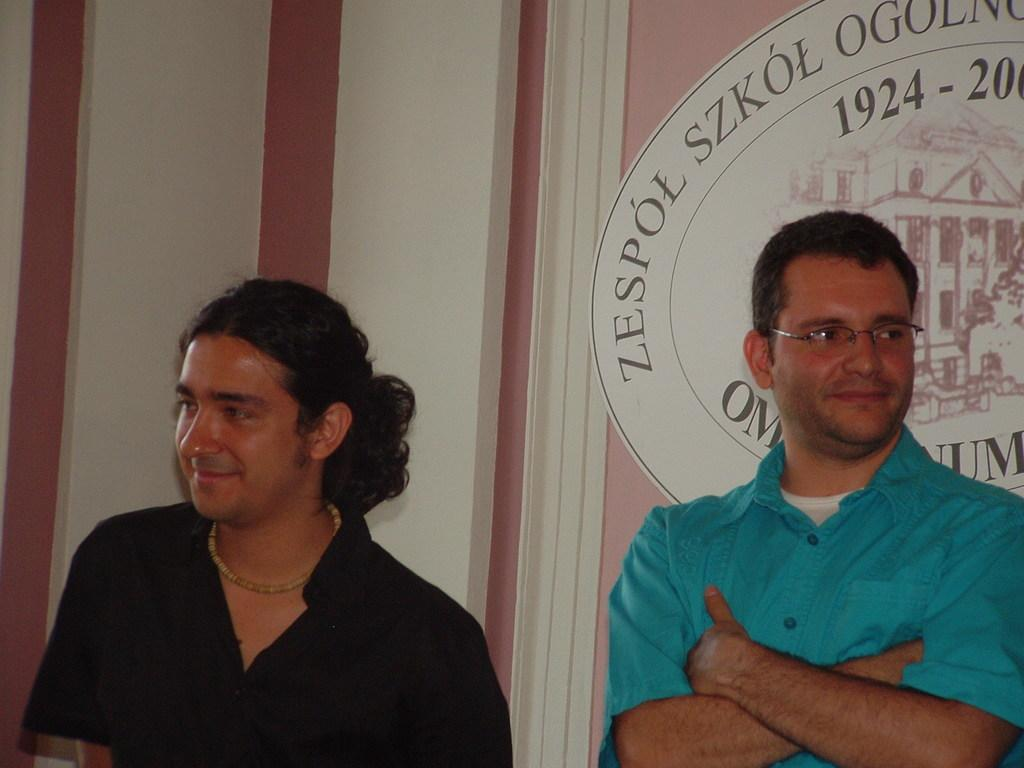How many men are present in the image? There are two men in the image. What are the men doing in the image? The men are standing and smiling. What can be seen on the white board in the image? There is an image of a building and numbers on the board. What type of yam is being used to draw the building on the white board? There is no yam present in the image, and the building on the white board is not drawn with any yam. 